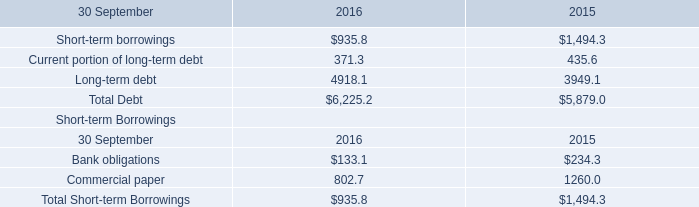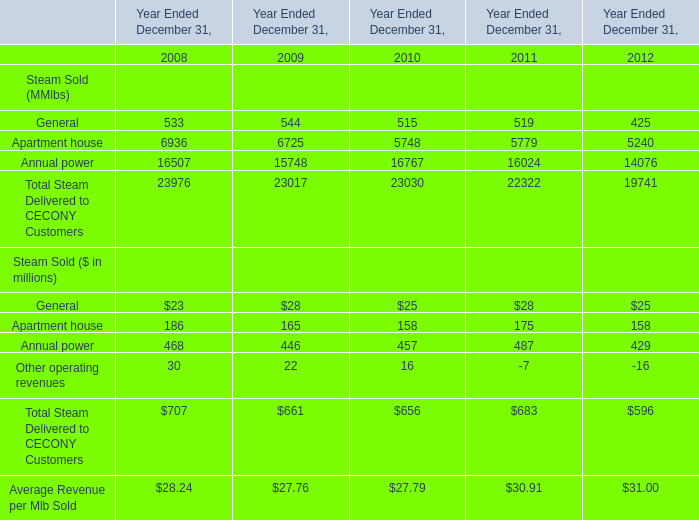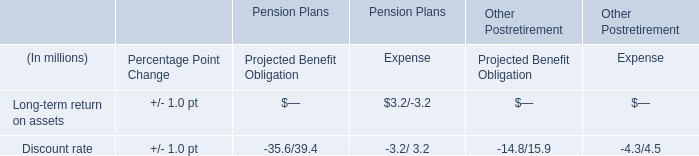considering the year 2016 , what is the short-term debt as a percent of total debt? 
Computations: ((935.8 + 371.3) / 6225.2)
Answer: 0.20997. 